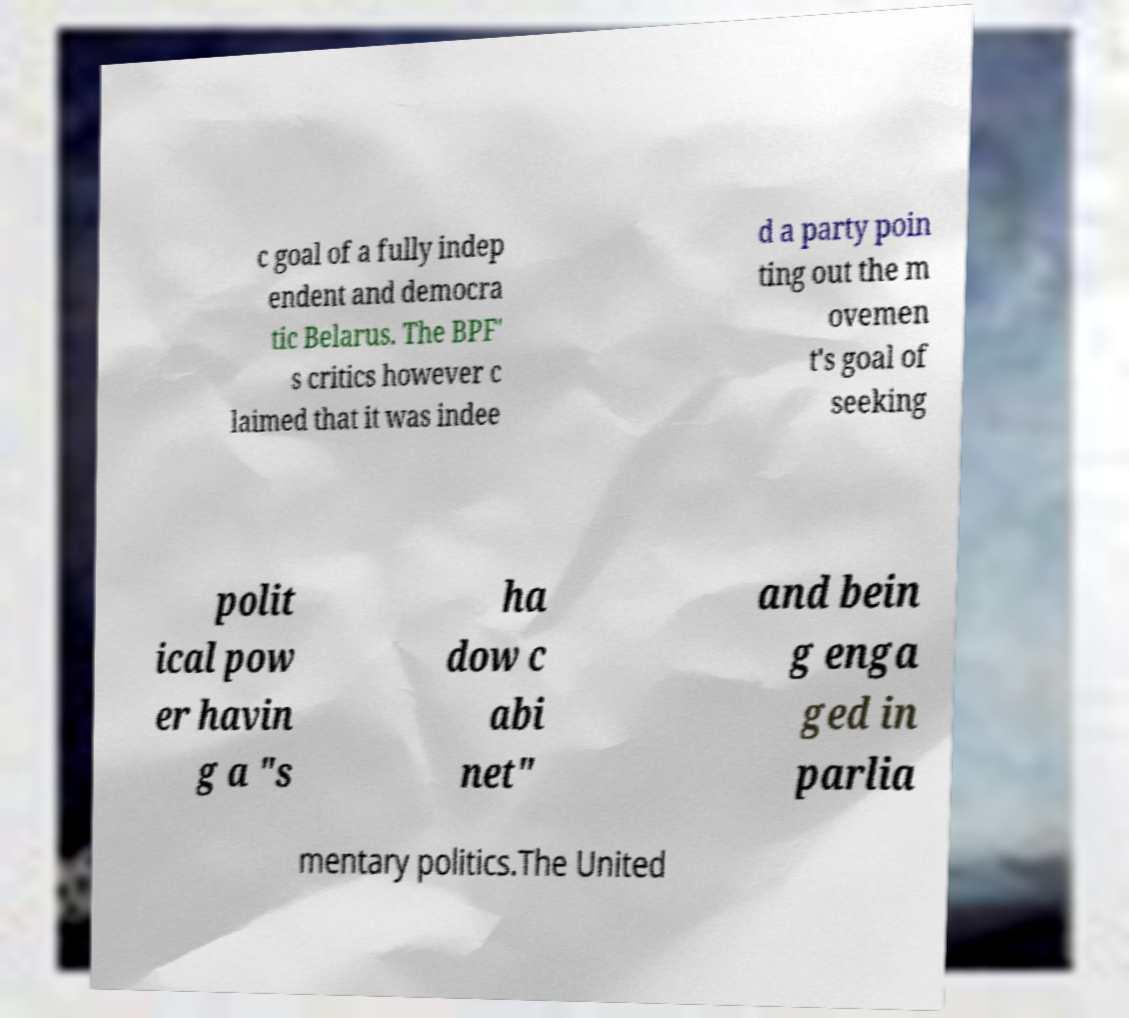Could you assist in decoding the text presented in this image and type it out clearly? c goal of a fully indep endent and democra tic Belarus. The BPF' s critics however c laimed that it was indee d a party poin ting out the m ovemen t's goal of seeking polit ical pow er havin g a "s ha dow c abi net" and bein g enga ged in parlia mentary politics.The United 